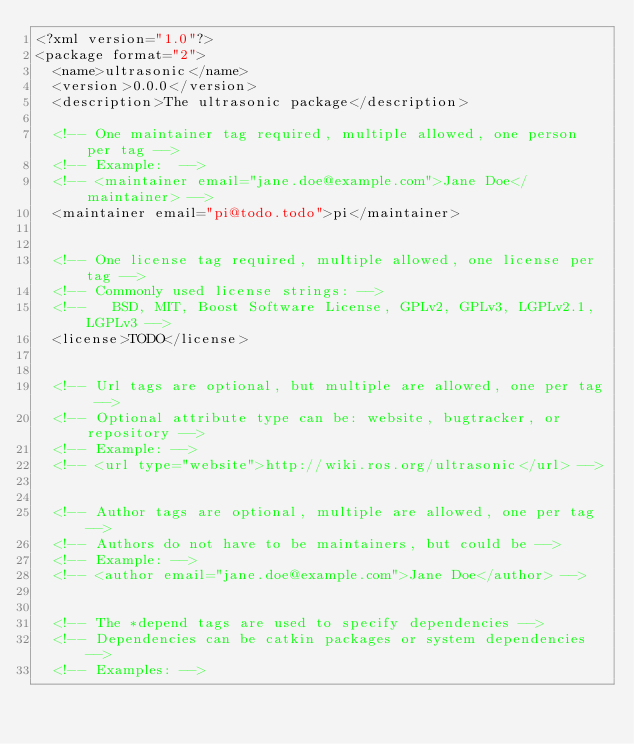Convert code to text. <code><loc_0><loc_0><loc_500><loc_500><_XML_><?xml version="1.0"?>
<package format="2">
  <name>ultrasonic</name>
  <version>0.0.0</version>
  <description>The ultrasonic package</description>

  <!-- One maintainer tag required, multiple allowed, one person per tag -->
  <!-- Example:  -->
  <!-- <maintainer email="jane.doe@example.com">Jane Doe</maintainer> -->
  <maintainer email="pi@todo.todo">pi</maintainer>


  <!-- One license tag required, multiple allowed, one license per tag -->
  <!-- Commonly used license strings: -->
  <!--   BSD, MIT, Boost Software License, GPLv2, GPLv3, LGPLv2.1, LGPLv3 -->
  <license>TODO</license>


  <!-- Url tags are optional, but multiple are allowed, one per tag -->
  <!-- Optional attribute type can be: website, bugtracker, or repository -->
  <!-- Example: -->
  <!-- <url type="website">http://wiki.ros.org/ultrasonic</url> -->


  <!-- Author tags are optional, multiple are allowed, one per tag -->
  <!-- Authors do not have to be maintainers, but could be -->
  <!-- Example: -->
  <!-- <author email="jane.doe@example.com">Jane Doe</author> -->


  <!-- The *depend tags are used to specify dependencies -->
  <!-- Dependencies can be catkin packages or system dependencies -->
  <!-- Examples: --></code> 